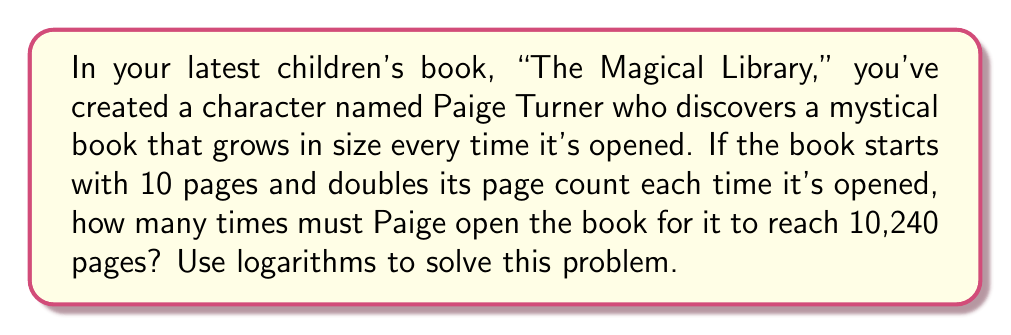Show me your answer to this math problem. Let's approach this step-by-step:

1) Let $x$ be the number of times Paige opens the book.

2) We can express the number of pages after $x$ openings as:
   $10 \cdot 2^x = 10,240$

3) Dividing both sides by 10:
   $2^x = 1,024$

4) Now, we can apply the logarithm (base 2) to both sides:
   $\log_2(2^x) = \log_2(1,024)$

5) Using the logarithm property $\log_a(a^x) = x$:
   $x = \log_2(1,024)$

6) We can simplify this further:
   $1,024 = 2^{10}$, so:
   $x = \log_2(2^{10}) = 10$

Therefore, Paige must open the book 10 times for it to reach 10,240 pages.
Answer: 10 times 